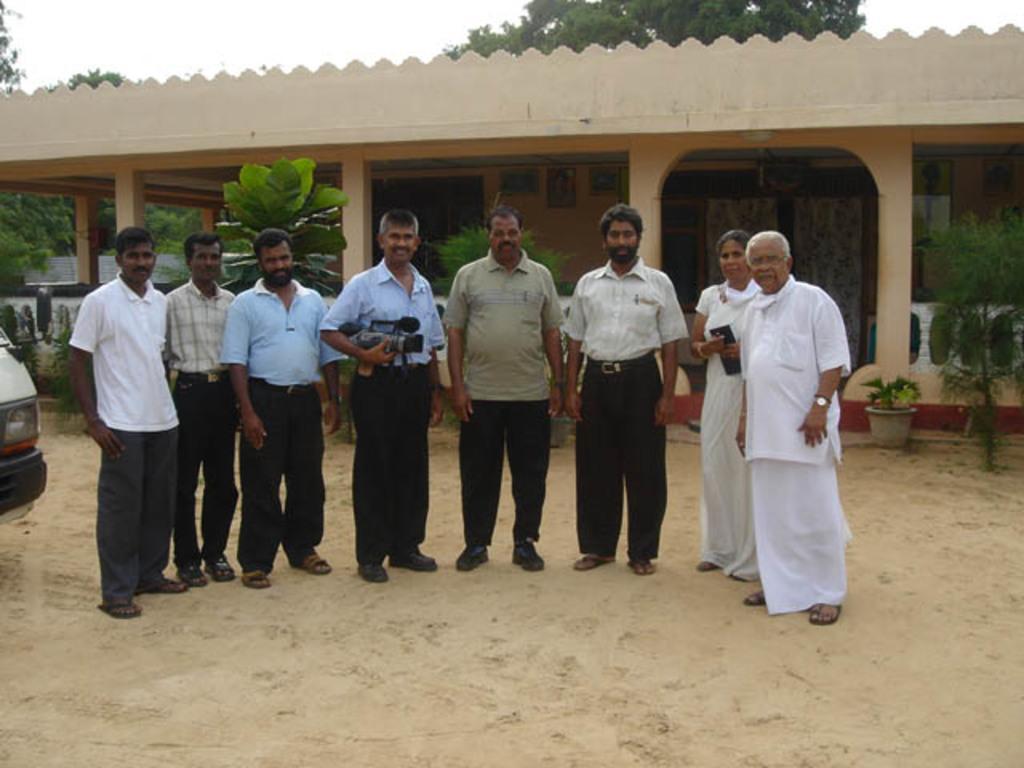Could you give a brief overview of what you see in this image? In this picture there are group of people standing and there is man standing and holding the camera and there is a woman standing and holding the book. At the back there is a building and there are trees and there are frames on the wall and there are curtains. On the left side of the image there is a vehicle. At the top there is sky. At the bottom there is ground. 